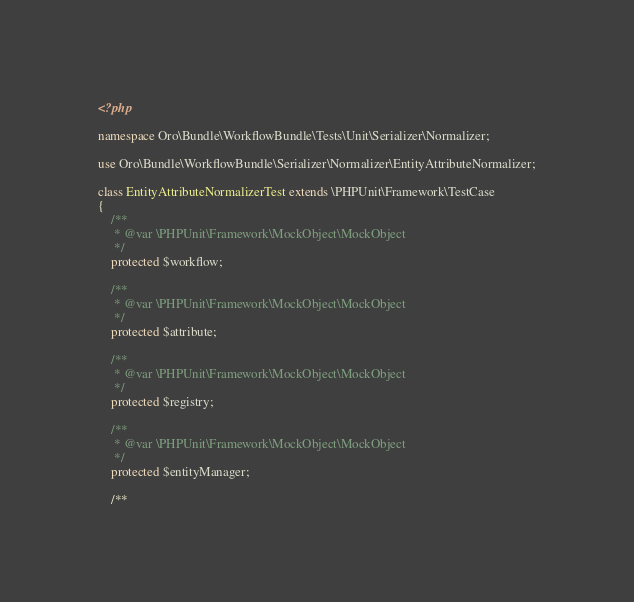Convert code to text. <code><loc_0><loc_0><loc_500><loc_500><_PHP_><?php

namespace Oro\Bundle\WorkflowBundle\Tests\Unit\Serializer\Normalizer;

use Oro\Bundle\WorkflowBundle\Serializer\Normalizer\EntityAttributeNormalizer;

class EntityAttributeNormalizerTest extends \PHPUnit\Framework\TestCase
{
    /**
     * @var \PHPUnit\Framework\MockObject\MockObject
     */
    protected $workflow;

    /**
     * @var \PHPUnit\Framework\MockObject\MockObject
     */
    protected $attribute;

    /**
     * @var \PHPUnit\Framework\MockObject\MockObject
     */
    protected $registry;

    /**
     * @var \PHPUnit\Framework\MockObject\MockObject
     */
    protected $entityManager;

    /**</code> 